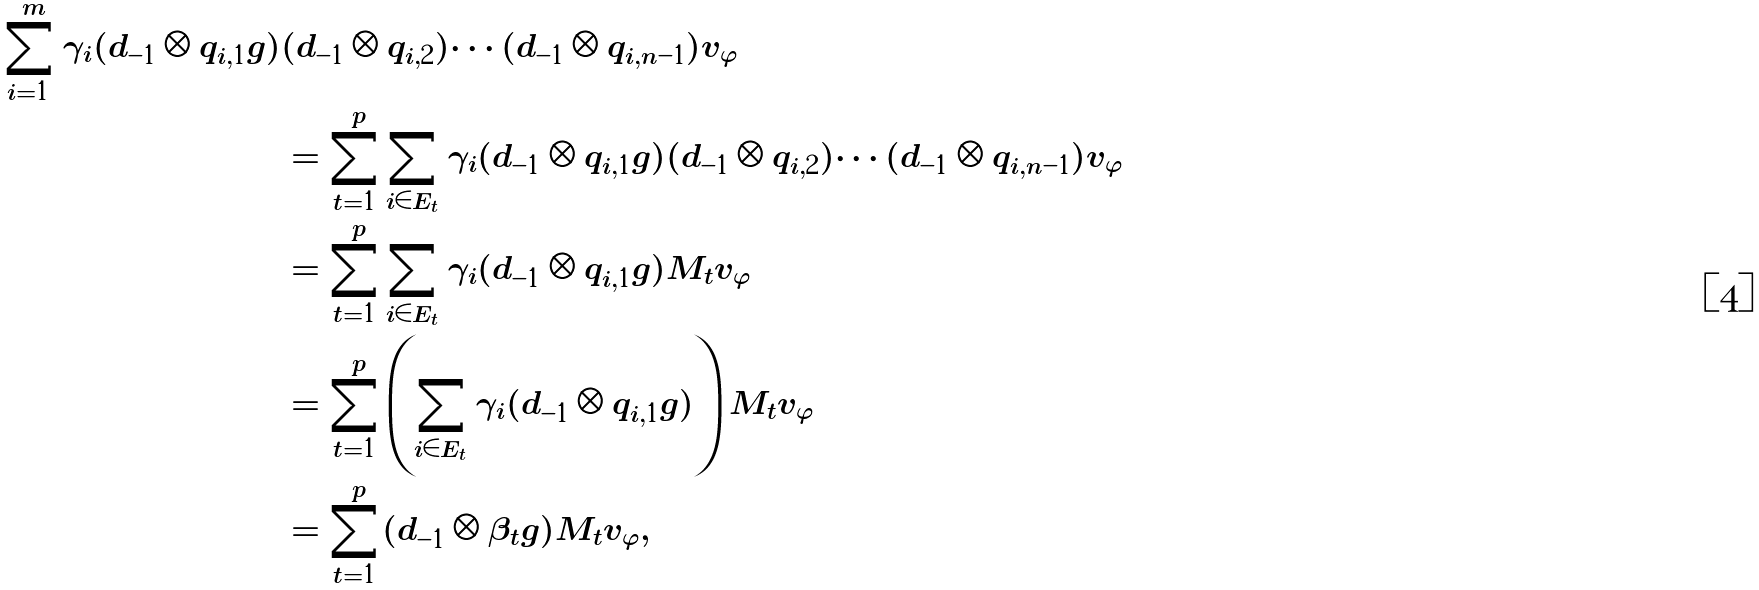<formula> <loc_0><loc_0><loc_500><loc_500>\sum _ { i = 1 } ^ { m } \gamma _ { i } ( d _ { - 1 } \otimes q _ { i , 1 } g ) & ( d _ { - 1 } \otimes q _ { i , 2 } ) \cdots ( d _ { - 1 } \otimes q _ { i , n - 1 } ) v _ { \varphi } \\ & = \sum _ { t = 1 } ^ { p } \sum _ { i \in E _ { t } } \gamma _ { i } ( d _ { - 1 } \otimes q _ { i , 1 } g ) ( d _ { - 1 } \otimes q _ { i , 2 } ) \cdots ( d _ { - 1 } \otimes q _ { i , n - 1 } ) v _ { \varphi } \\ & = \sum _ { t = 1 } ^ { p } \sum _ { i \in E _ { t } } \gamma _ { i } ( d _ { - 1 } \otimes q _ { i , 1 } g ) M _ { t } v _ { \varphi } \\ & = \sum _ { t = 1 } ^ { p } \left ( \sum _ { i \in E _ { t } } \gamma _ { i } ( d _ { - 1 } \otimes q _ { i , 1 } g ) \right ) M _ { t } v _ { \varphi } \\ & = \sum _ { t = 1 } ^ { p } ( d _ { - 1 } \otimes \beta _ { t } g ) M _ { t } v _ { \varphi } ,</formula> 